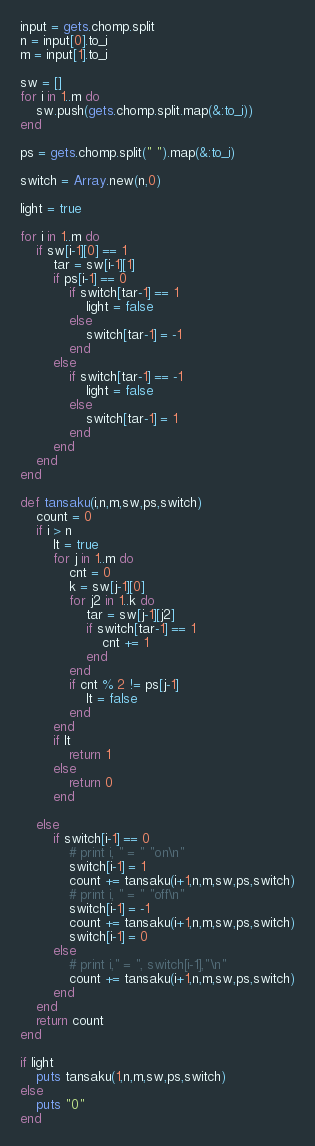Convert code to text. <code><loc_0><loc_0><loc_500><loc_500><_Ruby_>input = gets.chomp.split
n = input[0].to_i
m = input[1].to_i

sw = []
for i in 1..m do
    sw.push(gets.chomp.split.map(&:to_i))
end

ps = gets.chomp.split(" ").map(&:to_i)

switch = Array.new(n,0)

light = true

for i in 1..m do
    if sw[i-1][0] == 1
        tar = sw[i-1][1]
        if ps[i-1] == 0
            if switch[tar-1] == 1
                light = false
            else
                switch[tar-1] = -1
            end
        else
            if switch[tar-1] == -1
                light = false
            else
                switch[tar-1] = 1
            end
        end
    end
end

def tansaku(i,n,m,sw,ps,switch)
    count = 0
    if i > n
        lt = true
        for j in 1..m do
            cnt = 0
            k = sw[j-1][0]
            for j2 in 1..k do
                tar = sw[j-1][j2]
                if switch[tar-1] == 1
                    cnt += 1
                end
            end
            if cnt % 2 != ps[j-1]
                lt = false
            end
        end
        if lt 
            return 1
        else
            return 0
        end

    else
        if switch[i-1] == 0
            # print i, " = " "on\n" 
            switch[i-1] = 1
            count += tansaku(i+1,n,m,sw,ps,switch)
            # print i, " = " "off\n"
            switch[i-1] = -1
            count += tansaku(i+1,n,m,sw,ps,switch)
            switch[i-1] = 0
        else
            # print i," = ", switch[i-1],"\n"
            count += tansaku(i+1,n,m,sw,ps,switch)
        end
    end
    return count
end 

if light
    puts tansaku(1,n,m,sw,ps,switch)
else
    puts "0"
end</code> 